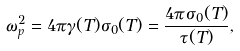Convert formula to latex. <formula><loc_0><loc_0><loc_500><loc_500>\omega _ { p } ^ { 2 } = 4 \pi \gamma ( T ) \sigma _ { 0 } ( T ) = \frac { 4 \pi \sigma _ { 0 } ( T ) } { \tau ( T ) } ,</formula> 